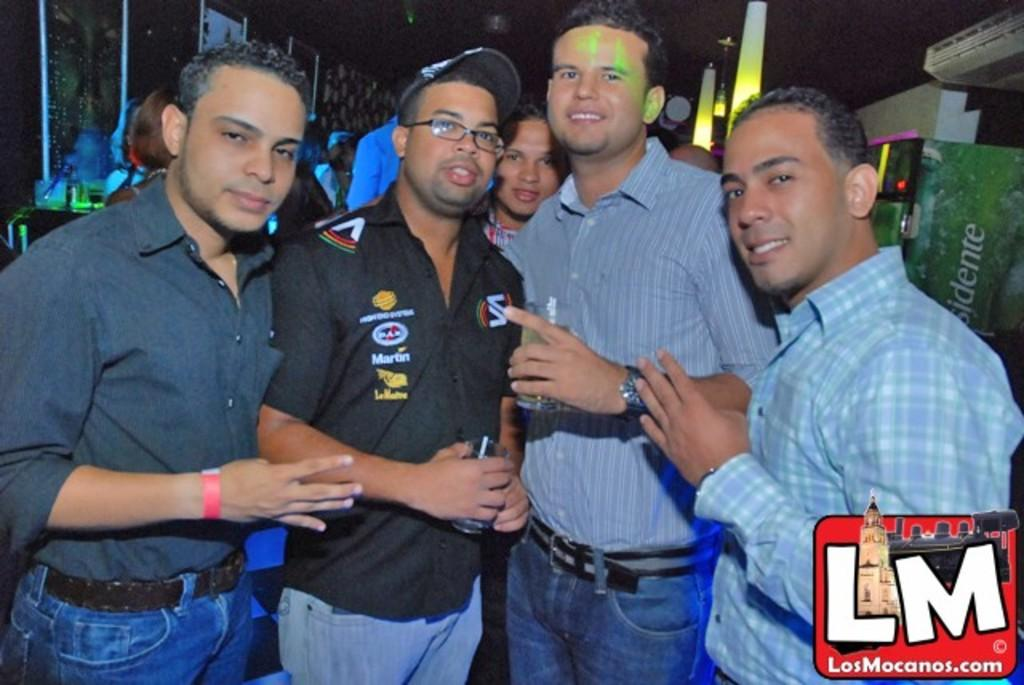What is happening in the image? There are people standing in the image. What can be seen in the background on the right side? There is a poster visible in the background on the right side. What else is present in the image? There are lights present in the image. What time of day is it in the image, and how much salt is on the ground? The time of day cannot be determined from the image, and there is no salt visible on the ground. 